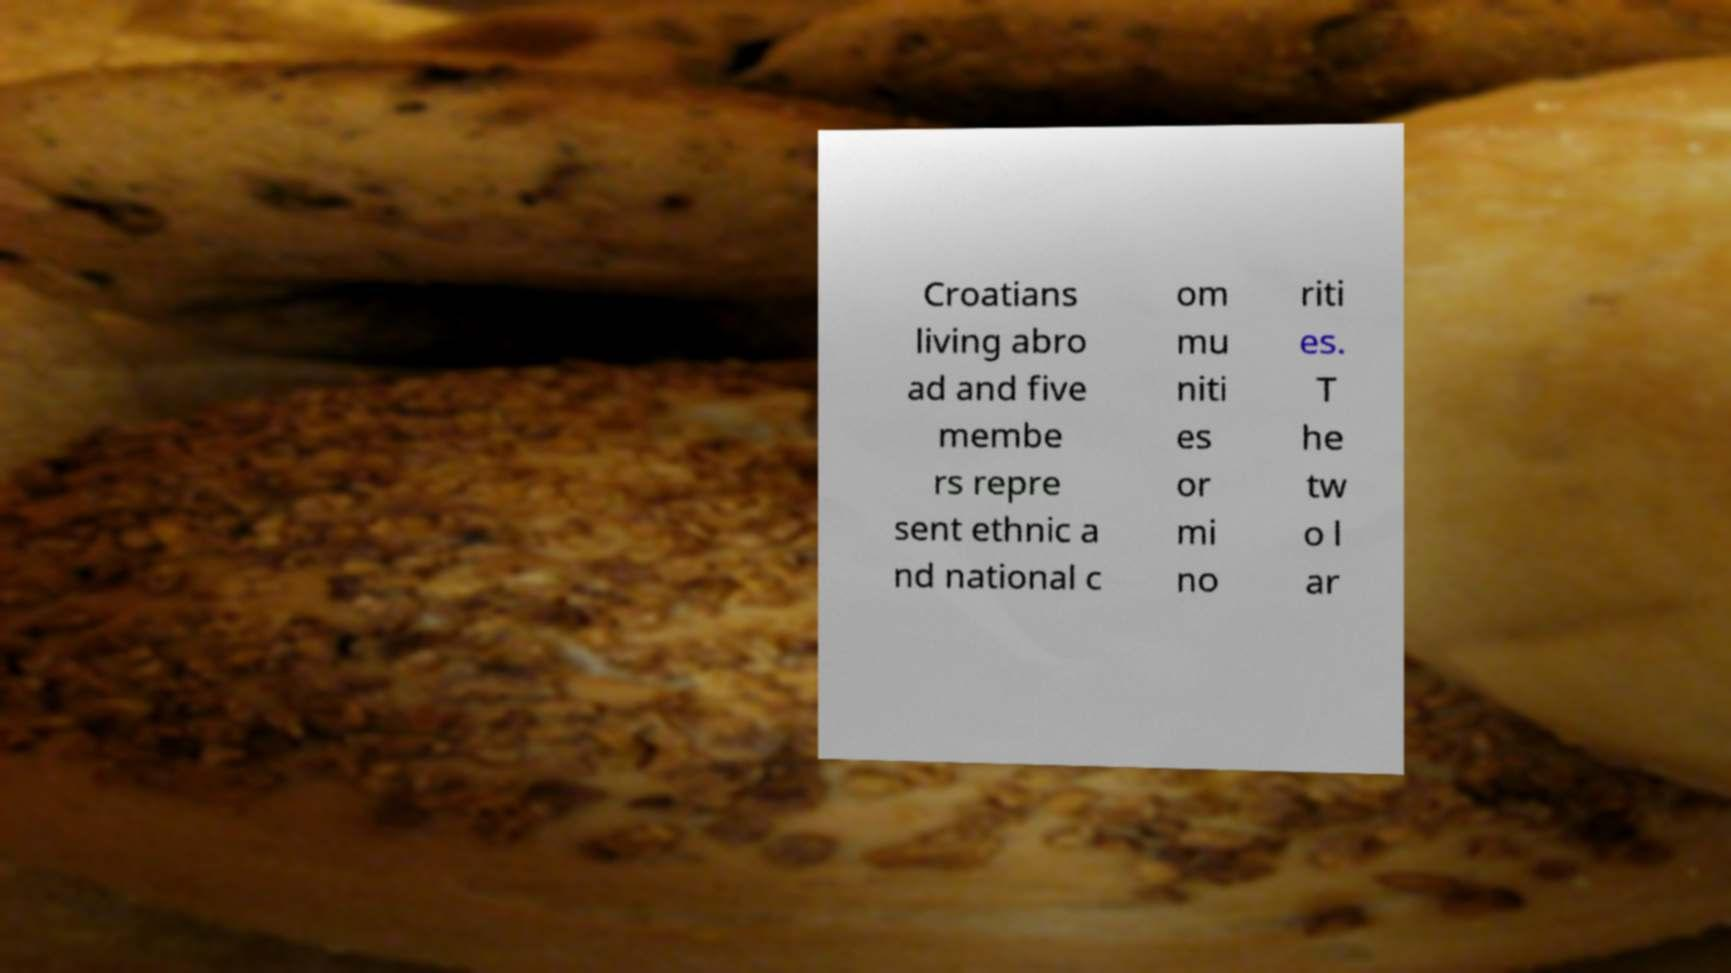There's text embedded in this image that I need extracted. Can you transcribe it verbatim? Croatians living abro ad and five membe rs repre sent ethnic a nd national c om mu niti es or mi no riti es. T he tw o l ar 